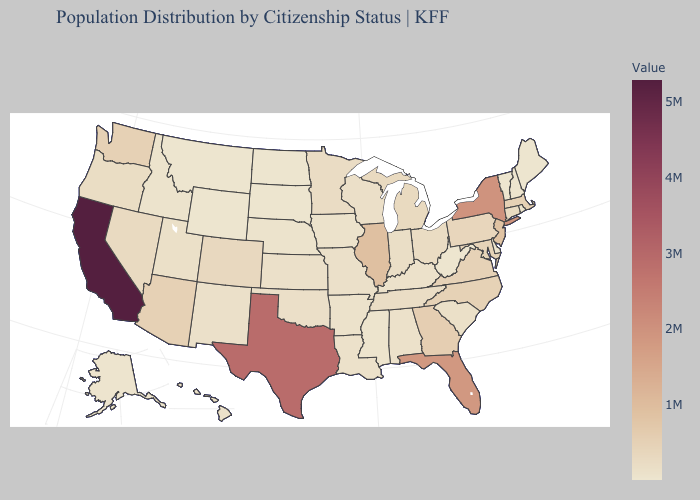Which states have the highest value in the USA?
Be succinct. California. Does Pennsylvania have a higher value than Florida?
Quick response, please. No. Among the states that border Connecticut , which have the highest value?
Write a very short answer. New York. Which states hav the highest value in the MidWest?
Concise answer only. Illinois. Does Maine have the lowest value in the Northeast?
Keep it brief. No. Is the legend a continuous bar?
Keep it brief. Yes. Does Maine have the lowest value in the USA?
Quick response, please. No. 